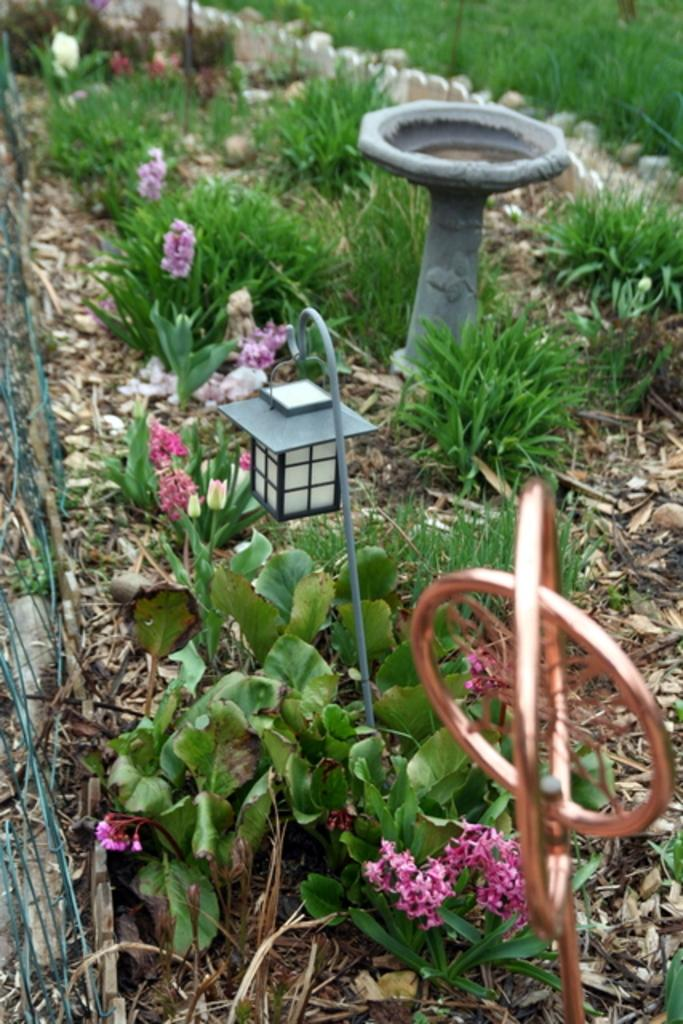What type of vegetation is in the center of the image? There is grass in the center of the image. What other types of plants can be seen in the image? There are plants with flowers in the image. What artificial light source is present in the image? There is a lamp in the image. Can you describe any other objects in the image? There are a few other objects in the image, but their specific details are not mentioned in the provided facts. What type of jam is being spread on the pipe in the image? There is no jam or pipe present in the image. 